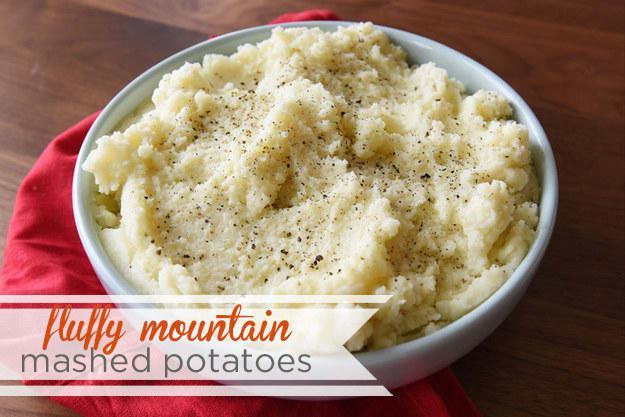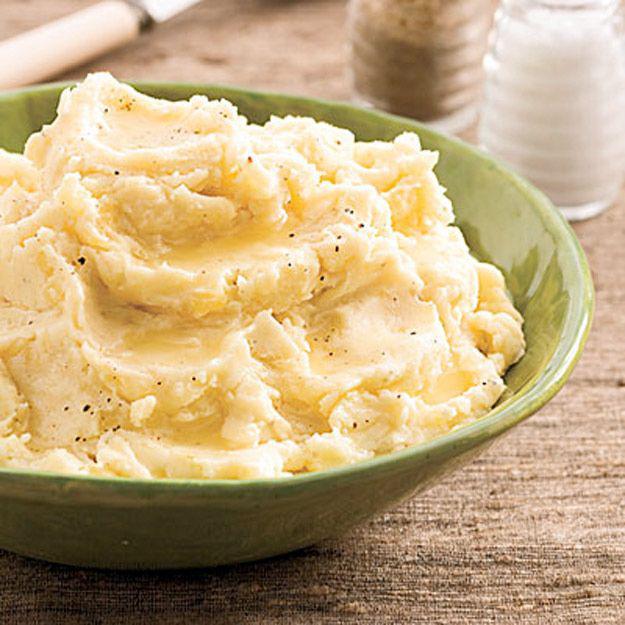The first image is the image on the left, the second image is the image on the right. For the images shown, is this caption "The right image contains a bowl of mashed potatoes with a spoon handle sticking out of  it." true? Answer yes or no. No. The first image is the image on the left, the second image is the image on the right. Examine the images to the left and right. Is the description "The right image shows mashed potatoes served in a bright red bowl, and no image shows a green garnish sprig on top of mashed potatoes." accurate? Answer yes or no. No. 